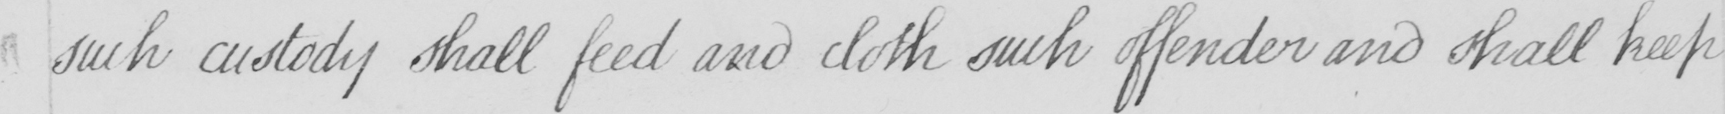What text is written in this handwritten line? such custody shall feed and cloth such offender and shall keep 